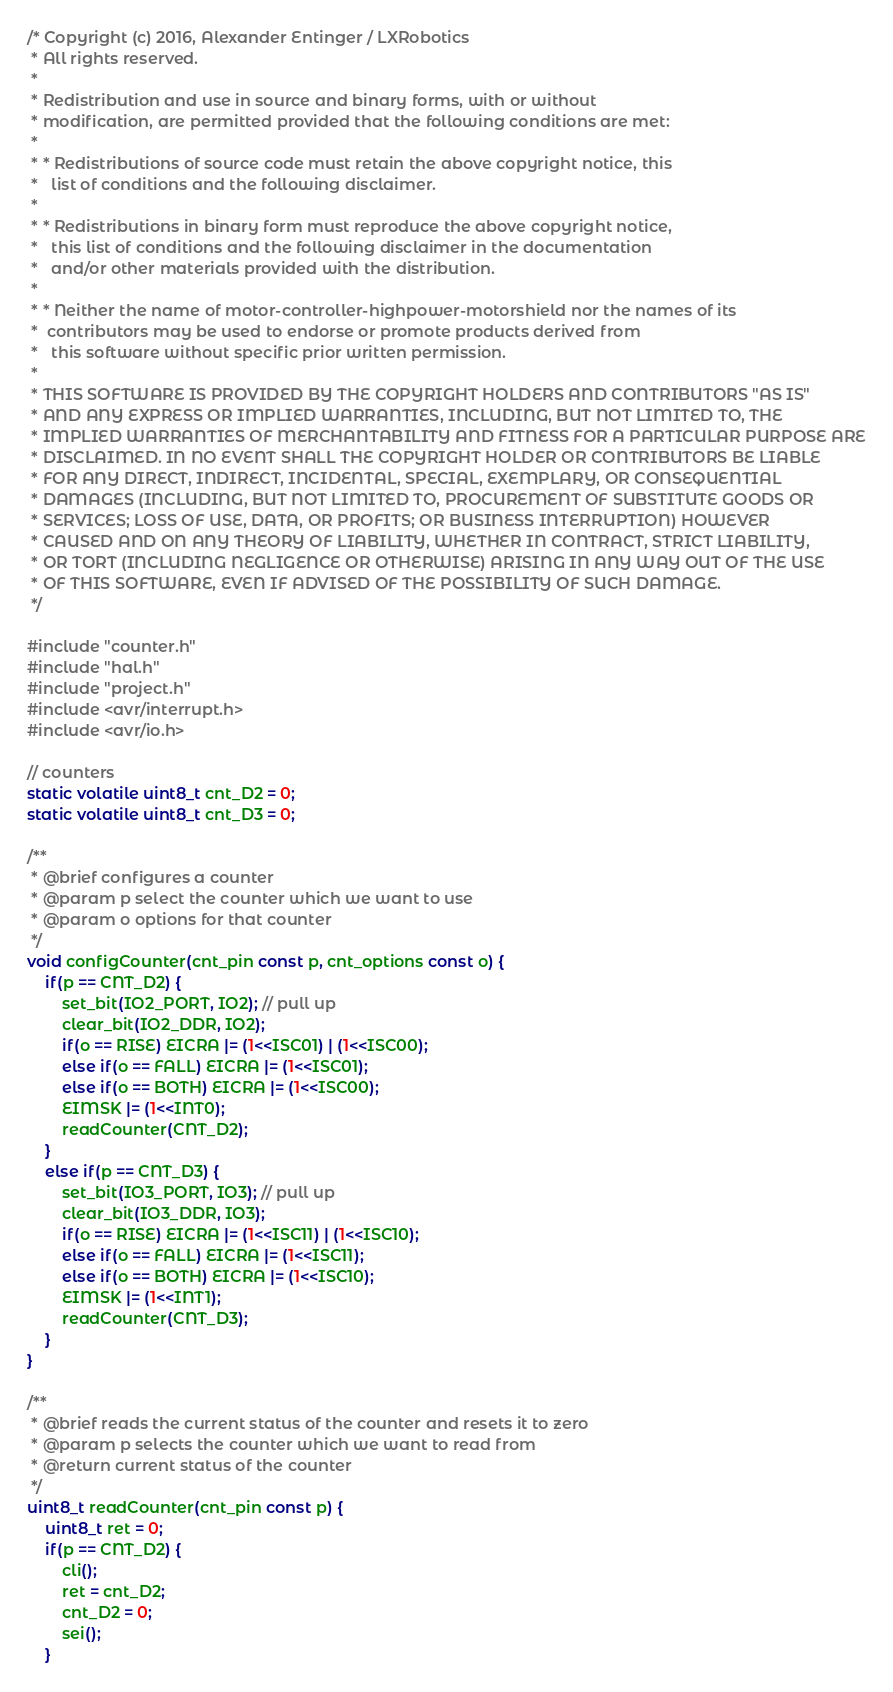Convert code to text. <code><loc_0><loc_0><loc_500><loc_500><_C_>/* Copyright (c) 2016, Alexander Entinger / LXRobotics
 * All rights reserved.
 * 
 * Redistribution and use in source and binary forms, with or without
 * modification, are permitted provided that the following conditions are met:
 * 
 * * Redistributions of source code must retain the above copyright notice, this
 *   list of conditions and the following disclaimer.
 * 
 * * Redistributions in binary form must reproduce the above copyright notice,
 *   this list of conditions and the following disclaimer in the documentation
 *   and/or other materials provided with the distribution.
 * 
 * * Neither the name of motor-controller-highpower-motorshield nor the names of its
 *  contributors may be used to endorse or promote products derived from
 *   this software without specific prior written permission.
 * 
 * THIS SOFTWARE IS PROVIDED BY THE COPYRIGHT HOLDERS AND CONTRIBUTORS "AS IS"
 * AND ANY EXPRESS OR IMPLIED WARRANTIES, INCLUDING, BUT NOT LIMITED TO, THE
 * IMPLIED WARRANTIES OF MERCHANTABILITY AND FITNESS FOR A PARTICULAR PURPOSE ARE
 * DISCLAIMED. IN NO EVENT SHALL THE COPYRIGHT HOLDER OR CONTRIBUTORS BE LIABLE
 * FOR ANY DIRECT, INDIRECT, INCIDENTAL, SPECIAL, EXEMPLARY, OR CONSEQUENTIAL
 * DAMAGES (INCLUDING, BUT NOT LIMITED TO, PROCUREMENT OF SUBSTITUTE GOODS OR
 * SERVICES; LOSS OF USE, DATA, OR PROFITS; OR BUSINESS INTERRUPTION) HOWEVER
 * CAUSED AND ON ANY THEORY OF LIABILITY, WHETHER IN CONTRACT, STRICT LIABILITY,
 * OR TORT (INCLUDING NEGLIGENCE OR OTHERWISE) ARISING IN ANY WAY OUT OF THE USE
 * OF THIS SOFTWARE, EVEN IF ADVISED OF THE POSSIBILITY OF SUCH DAMAGE.
 */

#include "counter.h"
#include "hal.h"
#include "project.h"
#include <avr/interrupt.h>
#include <avr/io.h>

// counters
static volatile uint8_t cnt_D2 = 0;
static volatile uint8_t cnt_D3 = 0;

/**
 * @brief configures a counter
 * @param p select the counter which we want to use
 * @param o options for that counter
 */
void configCounter(cnt_pin const p, cnt_options const o) {
	if(p == CNT_D2) {
		set_bit(IO2_PORT, IO2); // pull up
		clear_bit(IO2_DDR, IO2);
		if(o == RISE) EICRA |= (1<<ISC01) | (1<<ISC00);
		else if(o == FALL) EICRA |= (1<<ISC01);
		else if(o == BOTH) EICRA |= (1<<ISC00);
		EIMSK |= (1<<INT0);
		readCounter(CNT_D2);
	}
	else if(p == CNT_D3) {
		set_bit(IO3_PORT, IO3); // pull up
		clear_bit(IO3_DDR, IO3);
		if(o == RISE) EICRA |= (1<<ISC11) | (1<<ISC10);
		else if(o == FALL) EICRA |= (1<<ISC11);
		else if(o == BOTH) EICRA |= (1<<ISC10);
		EIMSK |= (1<<INT1);
		readCounter(CNT_D3);
	}
}

/**
 * @brief reads the current status of the counter and resets it to zero
 * @param p selects the counter which we want to read from
 * @return current status of the counter
 */
uint8_t readCounter(cnt_pin const p) {
	uint8_t ret = 0;
	if(p == CNT_D2) {
		cli();
		ret = cnt_D2;
		cnt_D2 = 0;
		sei();
	}</code> 